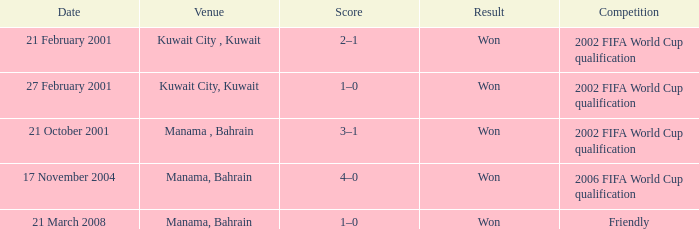What was the final score of the Friendly Competition in Manama, Bahrain? 1–0. 